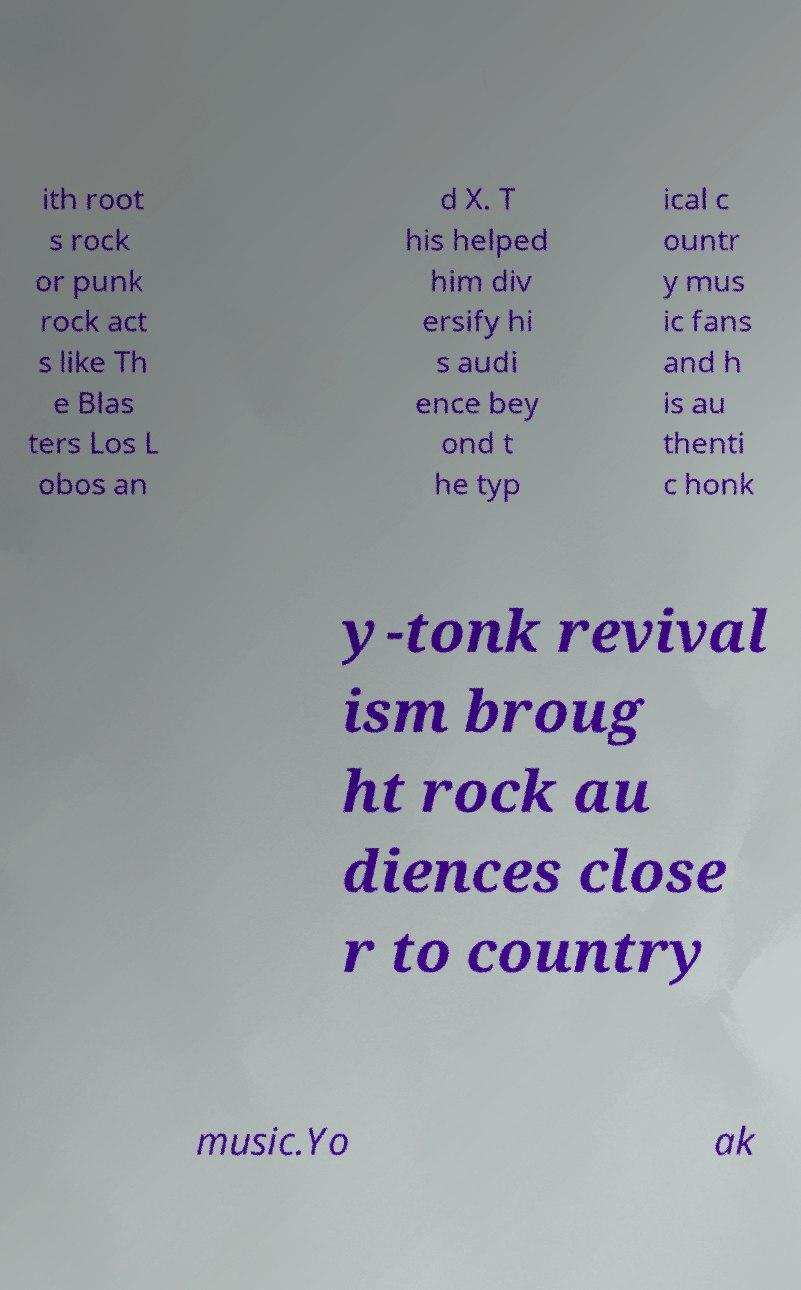What messages or text are displayed in this image? I need them in a readable, typed format. ith root s rock or punk rock act s like Th e Blas ters Los L obos an d X. T his helped him div ersify hi s audi ence bey ond t he typ ical c ountr y mus ic fans and h is au thenti c honk y-tonk revival ism broug ht rock au diences close r to country music.Yo ak 